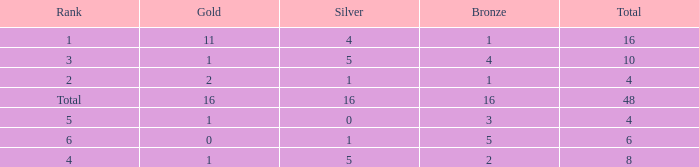What is the total gold that has bronze less than 2, a silver of 1 and total more than 4? None. 